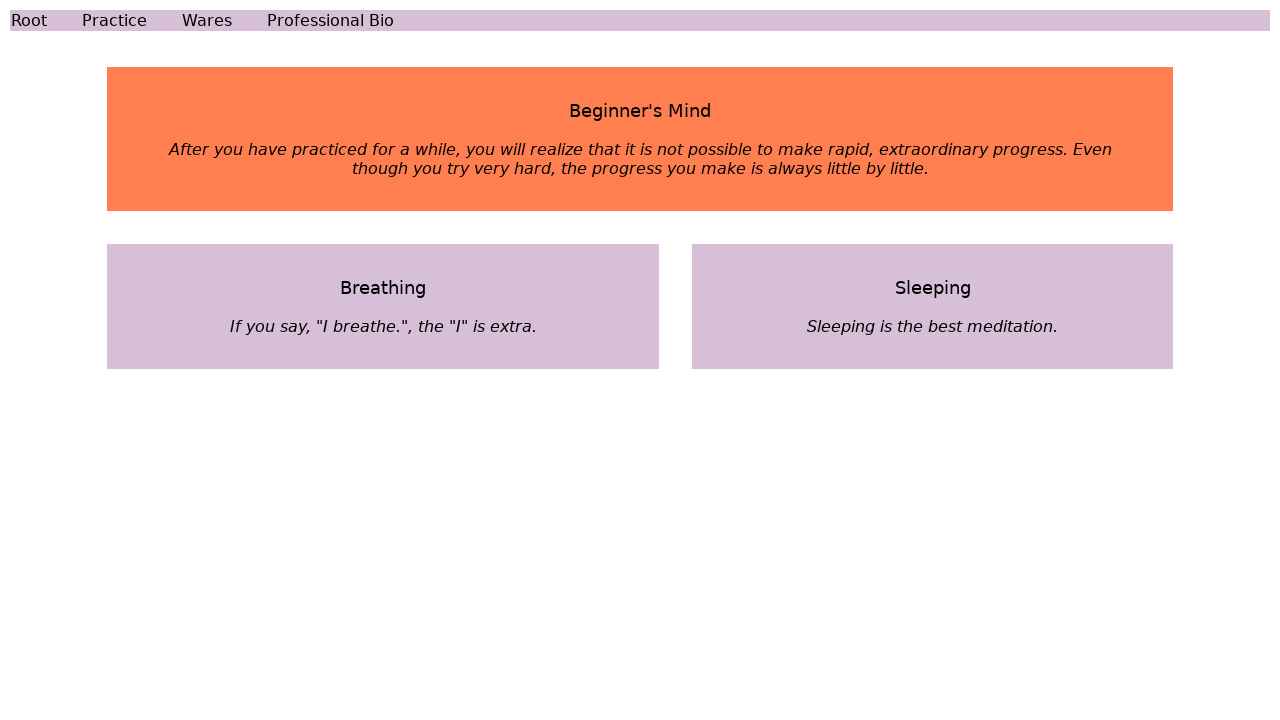What is the theme reflected in the color choices for this webpage? The theme reflected in the color choices of the webpage seems to focus on calmness and meditation. The shades of lavender and coral pink create a serene and mindful atmosphere, likely aimed at inducing relaxation and contemplation. 